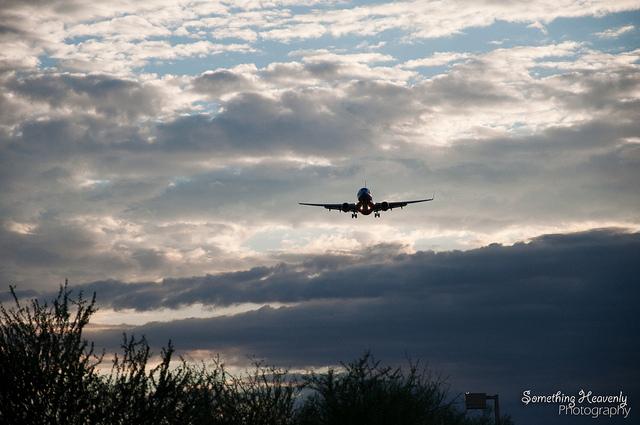What is the weather like in this image?
Short answer required. Cloudy. How many wheels are visible on the plane?
Concise answer only. 4. Is the image in black and white?
Write a very short answer. No. What type of jet is flying in the sky?
Short answer required. Passenger. Did this airplane just take off?
Write a very short answer. Yes. Is it a cloudy day?
Answer briefly. Yes. 